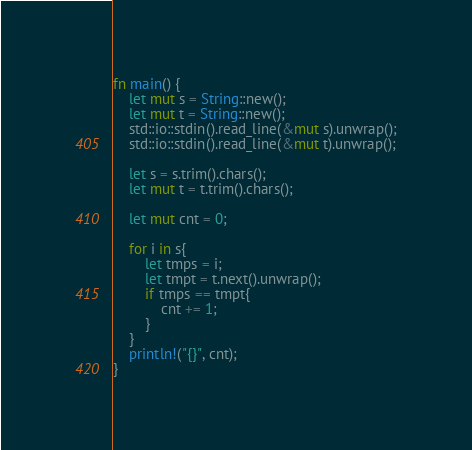Convert code to text. <code><loc_0><loc_0><loc_500><loc_500><_Rust_>fn main() {
    let mut s = String::new();
    let mut t = String::new();
    std::io::stdin().read_line(&mut s).unwrap();
    std::io::stdin().read_line(&mut t).unwrap();

    let s = s.trim().chars();
    let mut t = t.trim().chars();

    let mut cnt = 0;

    for i in s{
        let tmps = i;
        let tmpt = t.next().unwrap();
        if tmps == tmpt{
            cnt += 1;
        }
    }
    println!("{}", cnt);
}
</code> 